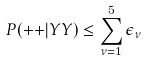<formula> <loc_0><loc_0><loc_500><loc_500>P ( { + + } | Y Y ) \leq \sum _ { \nu = 1 } ^ { 5 } \epsilon _ { \nu }</formula> 